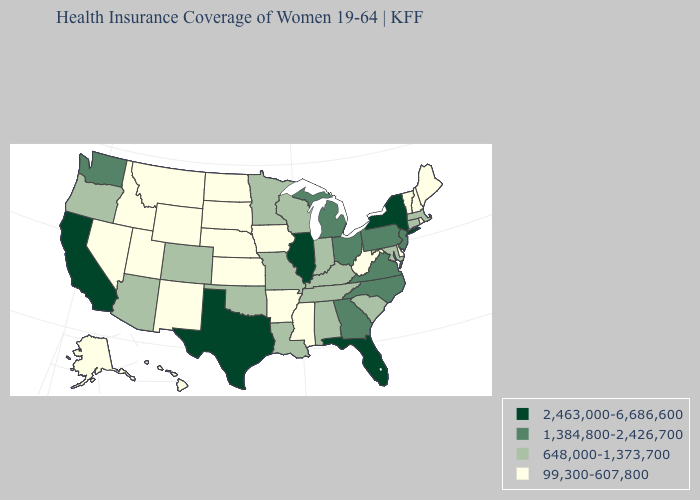What is the value of Rhode Island?
Short answer required. 99,300-607,800. What is the highest value in states that border Washington?
Write a very short answer. 648,000-1,373,700. What is the value of Arizona?
Keep it brief. 648,000-1,373,700. What is the lowest value in the MidWest?
Quick response, please. 99,300-607,800. What is the highest value in states that border Oklahoma?
Short answer required. 2,463,000-6,686,600. Name the states that have a value in the range 2,463,000-6,686,600?
Be succinct. California, Florida, Illinois, New York, Texas. Does Missouri have the lowest value in the MidWest?
Be succinct. No. What is the value of Indiana?
Give a very brief answer. 648,000-1,373,700. Does Ohio have the lowest value in the MidWest?
Be succinct. No. Name the states that have a value in the range 648,000-1,373,700?
Answer briefly. Alabama, Arizona, Colorado, Connecticut, Indiana, Kentucky, Louisiana, Maryland, Massachusetts, Minnesota, Missouri, Oklahoma, Oregon, South Carolina, Tennessee, Wisconsin. What is the lowest value in the West?
Short answer required. 99,300-607,800. Does California have the lowest value in the West?
Be succinct. No. What is the lowest value in the West?
Keep it brief. 99,300-607,800. Does North Dakota have the lowest value in the MidWest?
Be succinct. Yes. Name the states that have a value in the range 648,000-1,373,700?
Give a very brief answer. Alabama, Arizona, Colorado, Connecticut, Indiana, Kentucky, Louisiana, Maryland, Massachusetts, Minnesota, Missouri, Oklahoma, Oregon, South Carolina, Tennessee, Wisconsin. 